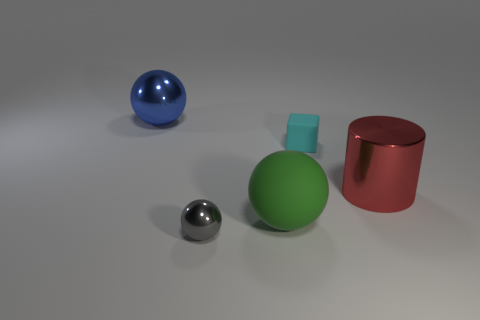Add 3 tiny cubes. How many objects exist? 8 Subtract all cubes. How many objects are left? 4 Subtract all big red cylinders. Subtract all tiny purple rubber balls. How many objects are left? 4 Add 3 shiny objects. How many shiny objects are left? 6 Add 1 tiny blue matte spheres. How many tiny blue matte spheres exist? 1 Subtract 0 yellow cylinders. How many objects are left? 5 